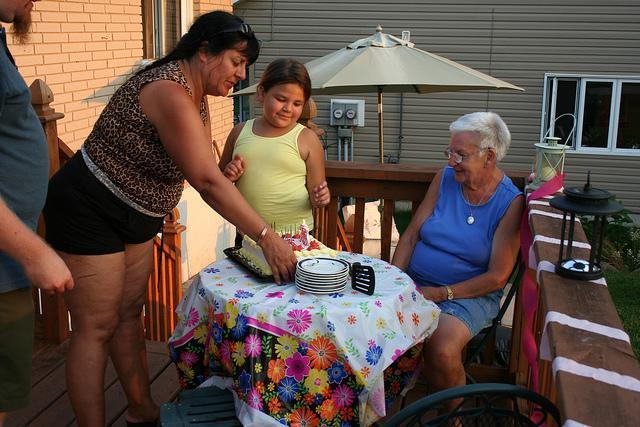How many people are there?
Give a very brief answer. 4. How many chairs are visible?
Give a very brief answer. 3. 